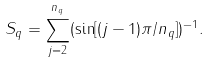Convert formula to latex. <formula><loc_0><loc_0><loc_500><loc_500>S _ { q } = \sum _ { j = 2 } ^ { n _ { q } } ( \sin [ ( j - 1 ) \pi / n _ { q } ] ) ^ { - 1 } .</formula> 